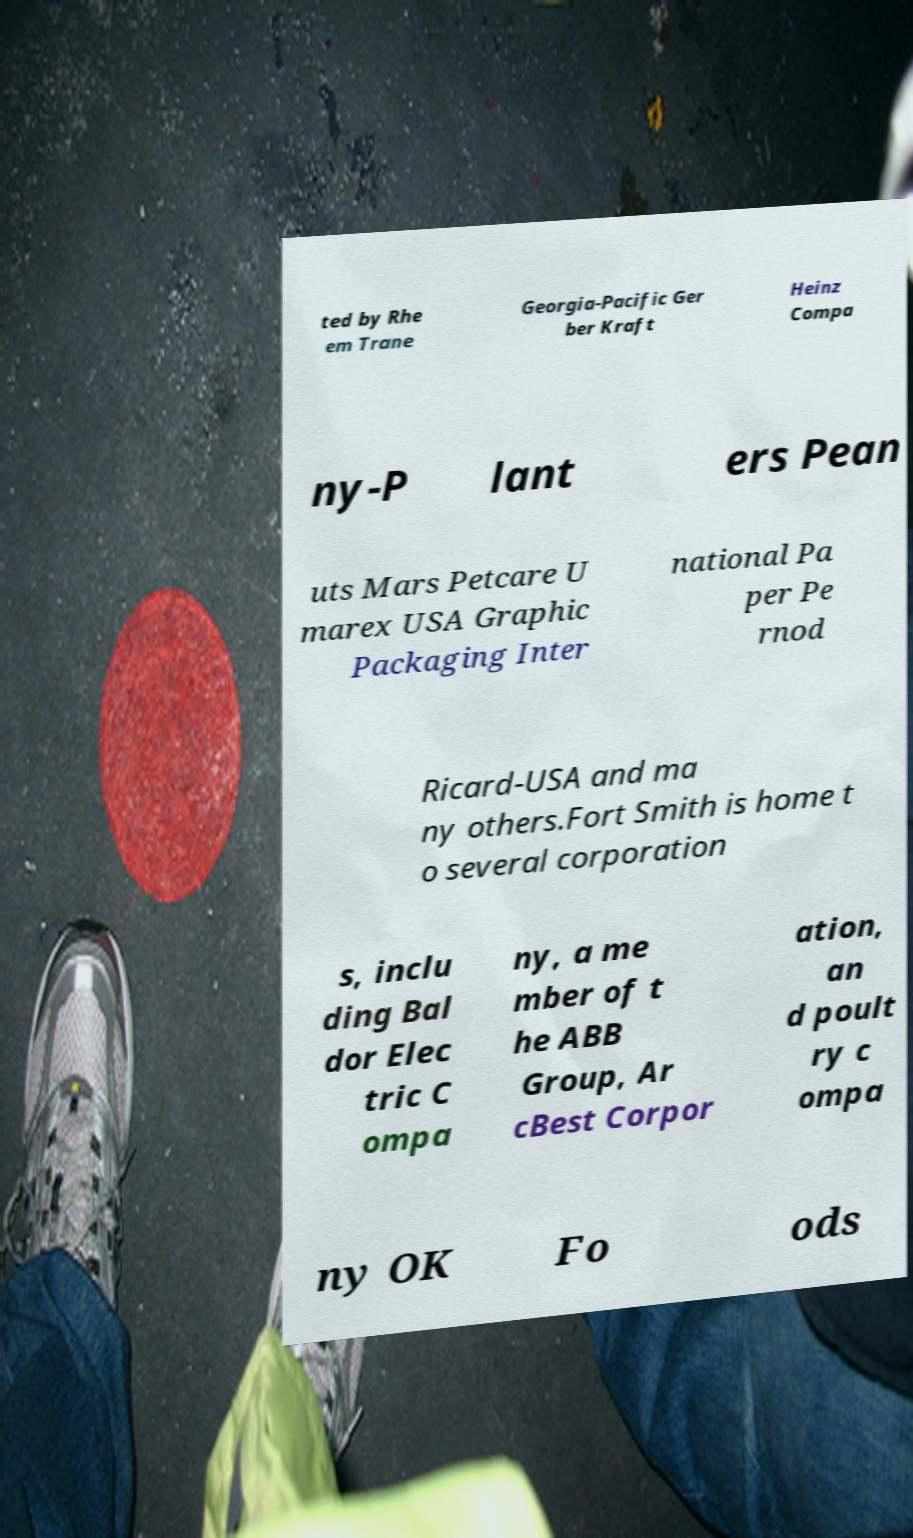Could you assist in decoding the text presented in this image and type it out clearly? ted by Rhe em Trane Georgia-Pacific Ger ber Kraft Heinz Compa ny-P lant ers Pean uts Mars Petcare U marex USA Graphic Packaging Inter national Pa per Pe rnod Ricard-USA and ma ny others.Fort Smith is home t o several corporation s, inclu ding Bal dor Elec tric C ompa ny, a me mber of t he ABB Group, Ar cBest Corpor ation, an d poult ry c ompa ny OK Fo ods 